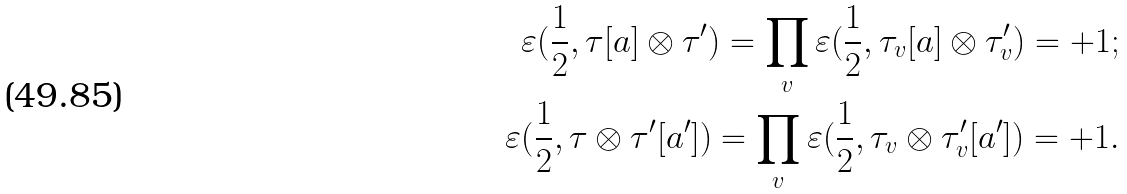<formula> <loc_0><loc_0><loc_500><loc_500>\varepsilon ( \frac { 1 } { 2 } , \tau [ a ] \otimes \tau ^ { \prime } ) = \prod _ { v } \varepsilon ( \frac { 1 } { 2 } , \tau _ { v } [ a ] \otimes \tau ^ { \prime } _ { v } ) = + 1 ; \\ \varepsilon ( \frac { 1 } { 2 } , \tau \otimes \tau ^ { \prime } [ a ^ { \prime } ] ) = \prod _ { v } \varepsilon ( \frac { 1 } { 2 } , \tau _ { v } \otimes \tau ^ { \prime } _ { v } [ a ^ { \prime } ] ) = + 1 .</formula> 